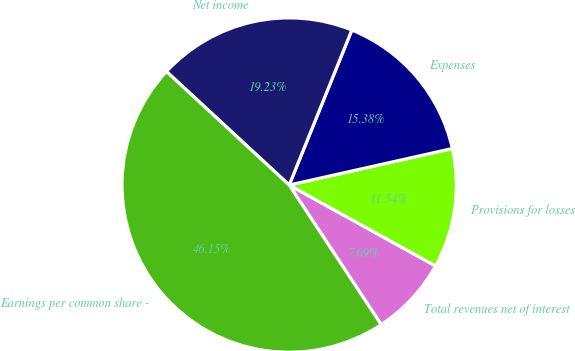<chart> <loc_0><loc_0><loc_500><loc_500><pie_chart><fcel>Total revenues net of interest<fcel>Provisions for losses<fcel>Expenses<fcel>Net income<fcel>Earnings per common share -<nl><fcel>7.69%<fcel>11.54%<fcel>15.38%<fcel>19.23%<fcel>46.15%<nl></chart> 